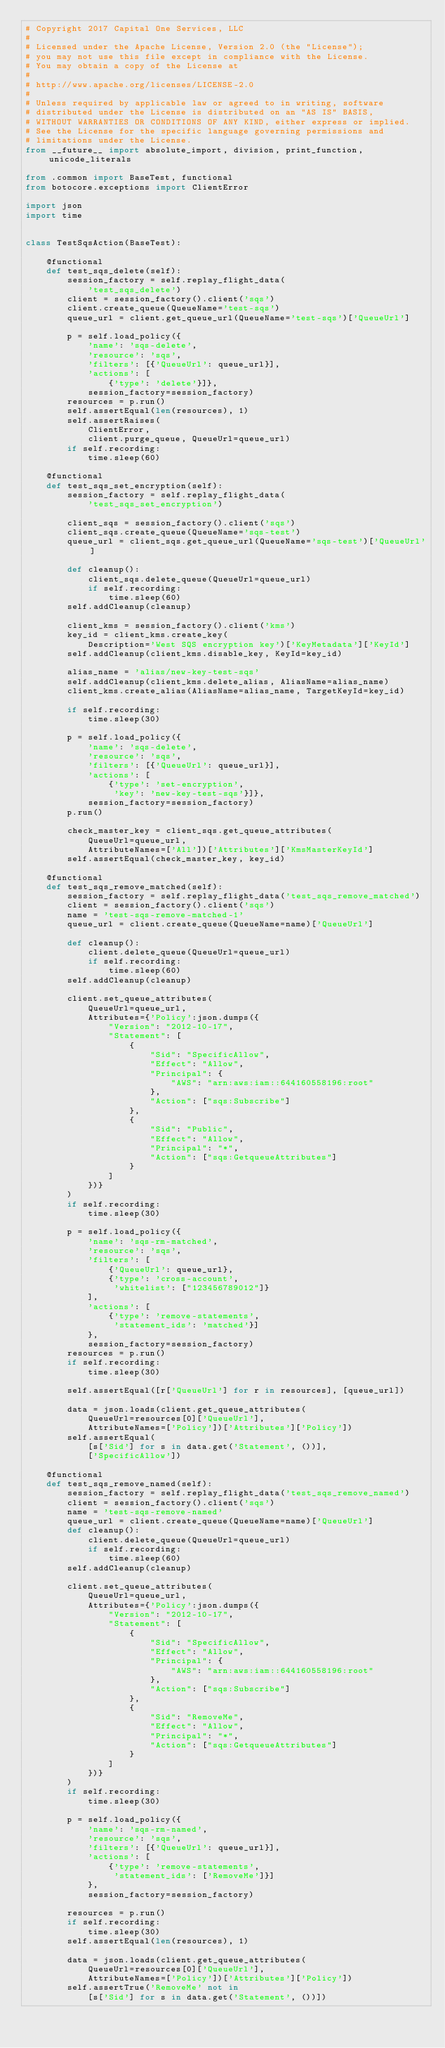Convert code to text. <code><loc_0><loc_0><loc_500><loc_500><_Python_># Copyright 2017 Capital One Services, LLC
#
# Licensed under the Apache License, Version 2.0 (the "License");
# you may not use this file except in compliance with the License.
# You may obtain a copy of the License at
#
# http://www.apache.org/licenses/LICENSE-2.0
#
# Unless required by applicable law or agreed to in writing, software
# distributed under the License is distributed on an "AS IS" BASIS,
# WITHOUT WARRANTIES OR CONDITIONS OF ANY KIND, either express or implied.
# See the License for the specific language governing permissions and
# limitations under the License.
from __future__ import absolute_import, division, print_function, unicode_literals

from .common import BaseTest, functional
from botocore.exceptions import ClientError

import json
import time


class TestSqsAction(BaseTest):

    @functional
    def test_sqs_delete(self):
        session_factory = self.replay_flight_data(
            'test_sqs_delete')
        client = session_factory().client('sqs')
        client.create_queue(QueueName='test-sqs')
        queue_url = client.get_queue_url(QueueName='test-sqs')['QueueUrl']

        p = self.load_policy({
            'name': 'sqs-delete',
            'resource': 'sqs',
            'filters': [{'QueueUrl': queue_url}],
            'actions': [
                {'type': 'delete'}]},
            session_factory=session_factory)
        resources = p.run()
        self.assertEqual(len(resources), 1)
        self.assertRaises(
            ClientError,
            client.purge_queue, QueueUrl=queue_url)
        if self.recording:
            time.sleep(60)

    @functional
    def test_sqs_set_encryption(self):
        session_factory = self.replay_flight_data(
            'test_sqs_set_encryption')

        client_sqs = session_factory().client('sqs')
        client_sqs.create_queue(QueueName='sqs-test')
        queue_url = client_sqs.get_queue_url(QueueName='sqs-test')['QueueUrl']

        def cleanup():
            client_sqs.delete_queue(QueueUrl=queue_url)
            if self.recording:
                time.sleep(60)
        self.addCleanup(cleanup)

        client_kms = session_factory().client('kms')
        key_id = client_kms.create_key(
            Description='West SQS encryption key')['KeyMetadata']['KeyId']
        self.addCleanup(client_kms.disable_key, KeyId=key_id)

        alias_name = 'alias/new-key-test-sqs'
        self.addCleanup(client_kms.delete_alias, AliasName=alias_name)
        client_kms.create_alias(AliasName=alias_name, TargetKeyId=key_id)

        if self.recording:
            time.sleep(30)

        p = self.load_policy({
            'name': 'sqs-delete',
            'resource': 'sqs',
            'filters': [{'QueueUrl': queue_url}],
            'actions': [
                {'type': 'set-encryption',
                 'key': 'new-key-test-sqs'}]},
            session_factory=session_factory)
        p.run()

        check_master_key = client_sqs.get_queue_attributes(
            QueueUrl=queue_url,
            AttributeNames=['All'])['Attributes']['KmsMasterKeyId']
        self.assertEqual(check_master_key, key_id)

    @functional
    def test_sqs_remove_matched(self):
        session_factory = self.replay_flight_data('test_sqs_remove_matched')
        client = session_factory().client('sqs')
        name = 'test-sqs-remove-matched-1'
        queue_url = client.create_queue(QueueName=name)['QueueUrl']

        def cleanup():
            client.delete_queue(QueueUrl=queue_url)
            if self.recording:
                time.sleep(60)
        self.addCleanup(cleanup)

        client.set_queue_attributes(
            QueueUrl=queue_url,
            Attributes={'Policy':json.dumps({
                "Version": "2012-10-17",
                "Statement": [
                    {
                        "Sid": "SpecificAllow",
                        "Effect": "Allow",
                        "Principal": {
                            "AWS": "arn:aws:iam::644160558196:root"
                        },
                        "Action": ["sqs:Subscribe"]
                    },
                    {
                        "Sid": "Public",
                        "Effect": "Allow",
                        "Principal": "*",
                        "Action": ["sqs:GetqueueAttributes"]
                    }
                ]
            })}
        )
        if self.recording:
            time.sleep(30)

        p = self.load_policy({
            'name': 'sqs-rm-matched',
            'resource': 'sqs',
            'filters': [
                {'QueueUrl': queue_url},
                {'type': 'cross-account',
                 'whitelist': ["123456789012"]}
            ],
            'actions': [
                {'type': 'remove-statements',
                 'statement_ids': 'matched'}]
            },
            session_factory=session_factory)
        resources = p.run()
        if self.recording:
            time.sleep(30)

        self.assertEqual([r['QueueUrl'] for r in resources], [queue_url])

        data = json.loads(client.get_queue_attributes(
            QueueUrl=resources[0]['QueueUrl'],
            AttributeNames=['Policy'])['Attributes']['Policy'])
        self.assertEqual(
            [s['Sid'] for s in data.get('Statement', ())],
            ['SpecificAllow'])

    @functional
    def test_sqs_remove_named(self):
        session_factory = self.replay_flight_data('test_sqs_remove_named')
        client = session_factory().client('sqs')
        name = 'test-sqs-remove-named'
        queue_url = client.create_queue(QueueName=name)['QueueUrl']
        def cleanup():
            client.delete_queue(QueueUrl=queue_url)
            if self.recording:
                time.sleep(60)
        self.addCleanup(cleanup)

        client.set_queue_attributes(
            QueueUrl=queue_url,
            Attributes={'Policy':json.dumps({
                "Version": "2012-10-17",
                "Statement": [
                    {
                        "Sid": "SpecificAllow",
                        "Effect": "Allow",
                        "Principal": {
                            "AWS": "arn:aws:iam::644160558196:root"
                        },
                        "Action": ["sqs:Subscribe"]
                    },
                    {
                        "Sid": "RemoveMe",
                        "Effect": "Allow",
                        "Principal": "*",
                        "Action": ["sqs:GetqueueAttributes"]
                    }
                ]
            })}
        )
        if self.recording:
            time.sleep(30)

        p = self.load_policy({
            'name': 'sqs-rm-named',
            'resource': 'sqs',
            'filters': [{'QueueUrl': queue_url}],
            'actions': [
                {'type': 'remove-statements',
                 'statement_ids': ['RemoveMe']}]
            },
            session_factory=session_factory)

        resources = p.run()
        if self.recording:
            time.sleep(30)
        self.assertEqual(len(resources), 1)

        data = json.loads(client.get_queue_attributes(
            QueueUrl=resources[0]['QueueUrl'],
            AttributeNames=['Policy'])['Attributes']['Policy'])
        self.assertTrue('RemoveMe' not in
            [s['Sid'] for s in data.get('Statement', ())])
</code> 